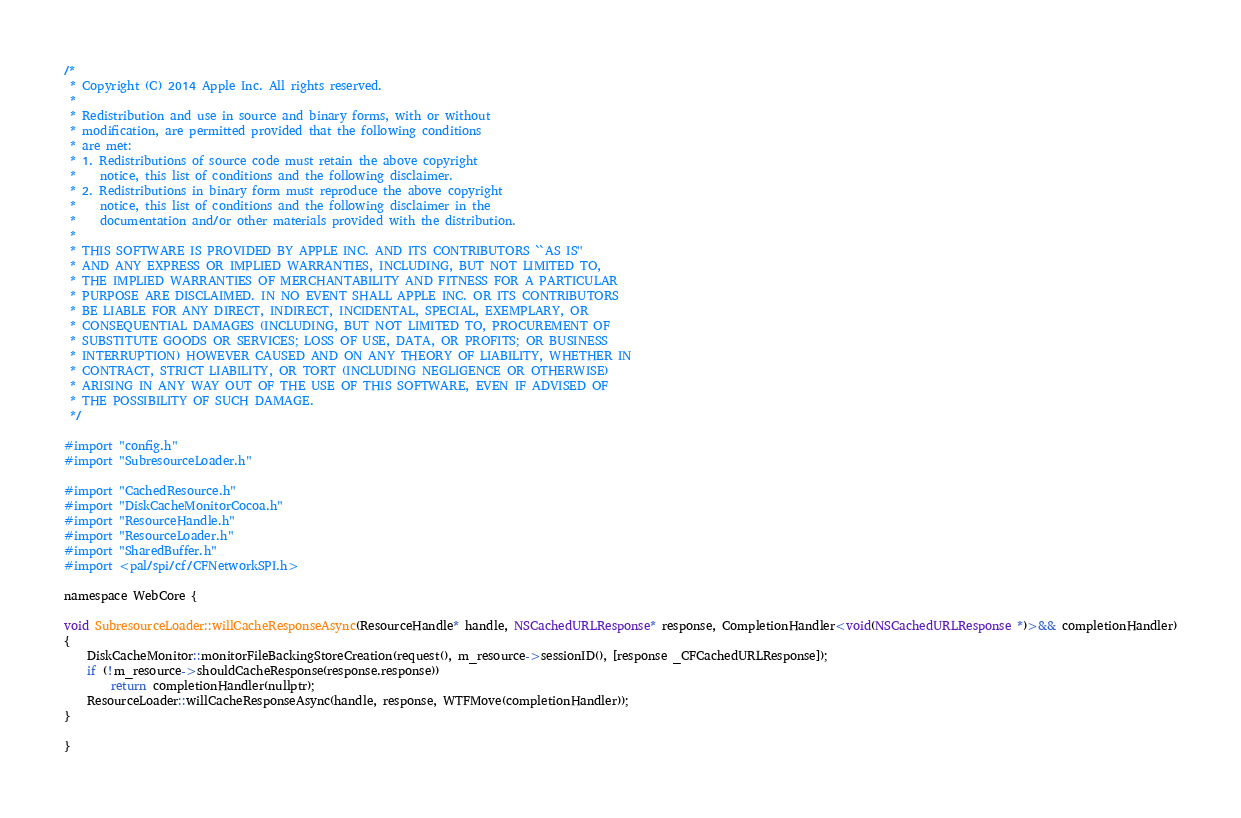Convert code to text. <code><loc_0><loc_0><loc_500><loc_500><_ObjectiveC_>/*
 * Copyright (C) 2014 Apple Inc. All rights reserved.
 *
 * Redistribution and use in source and binary forms, with or without
 * modification, are permitted provided that the following conditions
 * are met:
 * 1. Redistributions of source code must retain the above copyright
 *    notice, this list of conditions and the following disclaimer.
 * 2. Redistributions in binary form must reproduce the above copyright
 *    notice, this list of conditions and the following disclaimer in the
 *    documentation and/or other materials provided with the distribution.
 *
 * THIS SOFTWARE IS PROVIDED BY APPLE INC. AND ITS CONTRIBUTORS ``AS IS''
 * AND ANY EXPRESS OR IMPLIED WARRANTIES, INCLUDING, BUT NOT LIMITED TO,
 * THE IMPLIED WARRANTIES OF MERCHANTABILITY AND FITNESS FOR A PARTICULAR
 * PURPOSE ARE DISCLAIMED. IN NO EVENT SHALL APPLE INC. OR ITS CONTRIBUTORS
 * BE LIABLE FOR ANY DIRECT, INDIRECT, INCIDENTAL, SPECIAL, EXEMPLARY, OR
 * CONSEQUENTIAL DAMAGES (INCLUDING, BUT NOT LIMITED TO, PROCUREMENT OF
 * SUBSTITUTE GOODS OR SERVICES; LOSS OF USE, DATA, OR PROFITS; OR BUSINESS
 * INTERRUPTION) HOWEVER CAUSED AND ON ANY THEORY OF LIABILITY, WHETHER IN
 * CONTRACT, STRICT LIABILITY, OR TORT (INCLUDING NEGLIGENCE OR OTHERWISE)
 * ARISING IN ANY WAY OUT OF THE USE OF THIS SOFTWARE, EVEN IF ADVISED OF
 * THE POSSIBILITY OF SUCH DAMAGE.
 */

#import "config.h"
#import "SubresourceLoader.h"

#import "CachedResource.h"
#import "DiskCacheMonitorCocoa.h"
#import "ResourceHandle.h"
#import "ResourceLoader.h"
#import "SharedBuffer.h"
#import <pal/spi/cf/CFNetworkSPI.h>

namespace WebCore {

void SubresourceLoader::willCacheResponseAsync(ResourceHandle* handle, NSCachedURLResponse* response, CompletionHandler<void(NSCachedURLResponse *)>&& completionHandler)
{
    DiskCacheMonitor::monitorFileBackingStoreCreation(request(), m_resource->sessionID(), [response _CFCachedURLResponse]);
    if (!m_resource->shouldCacheResponse(response.response))
        return completionHandler(nullptr);
    ResourceLoader::willCacheResponseAsync(handle, response, WTFMove(completionHandler));
}

}
</code> 